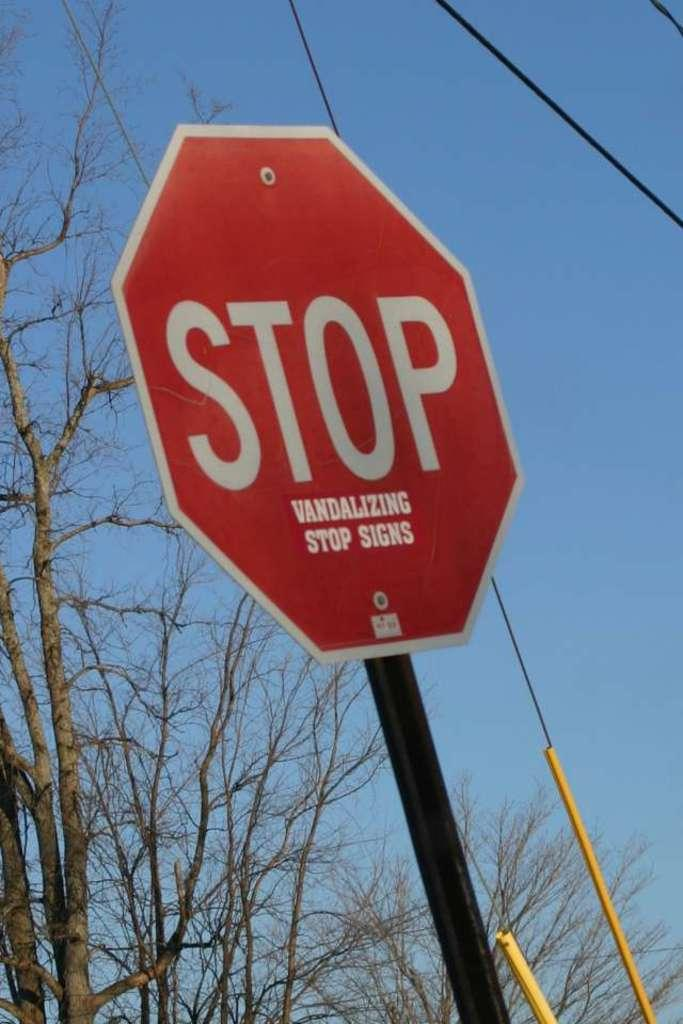<image>
Summarize the visual content of the image. In small letters, underneath the word Stop on a stop sign are the words vandalizing stop signs. 